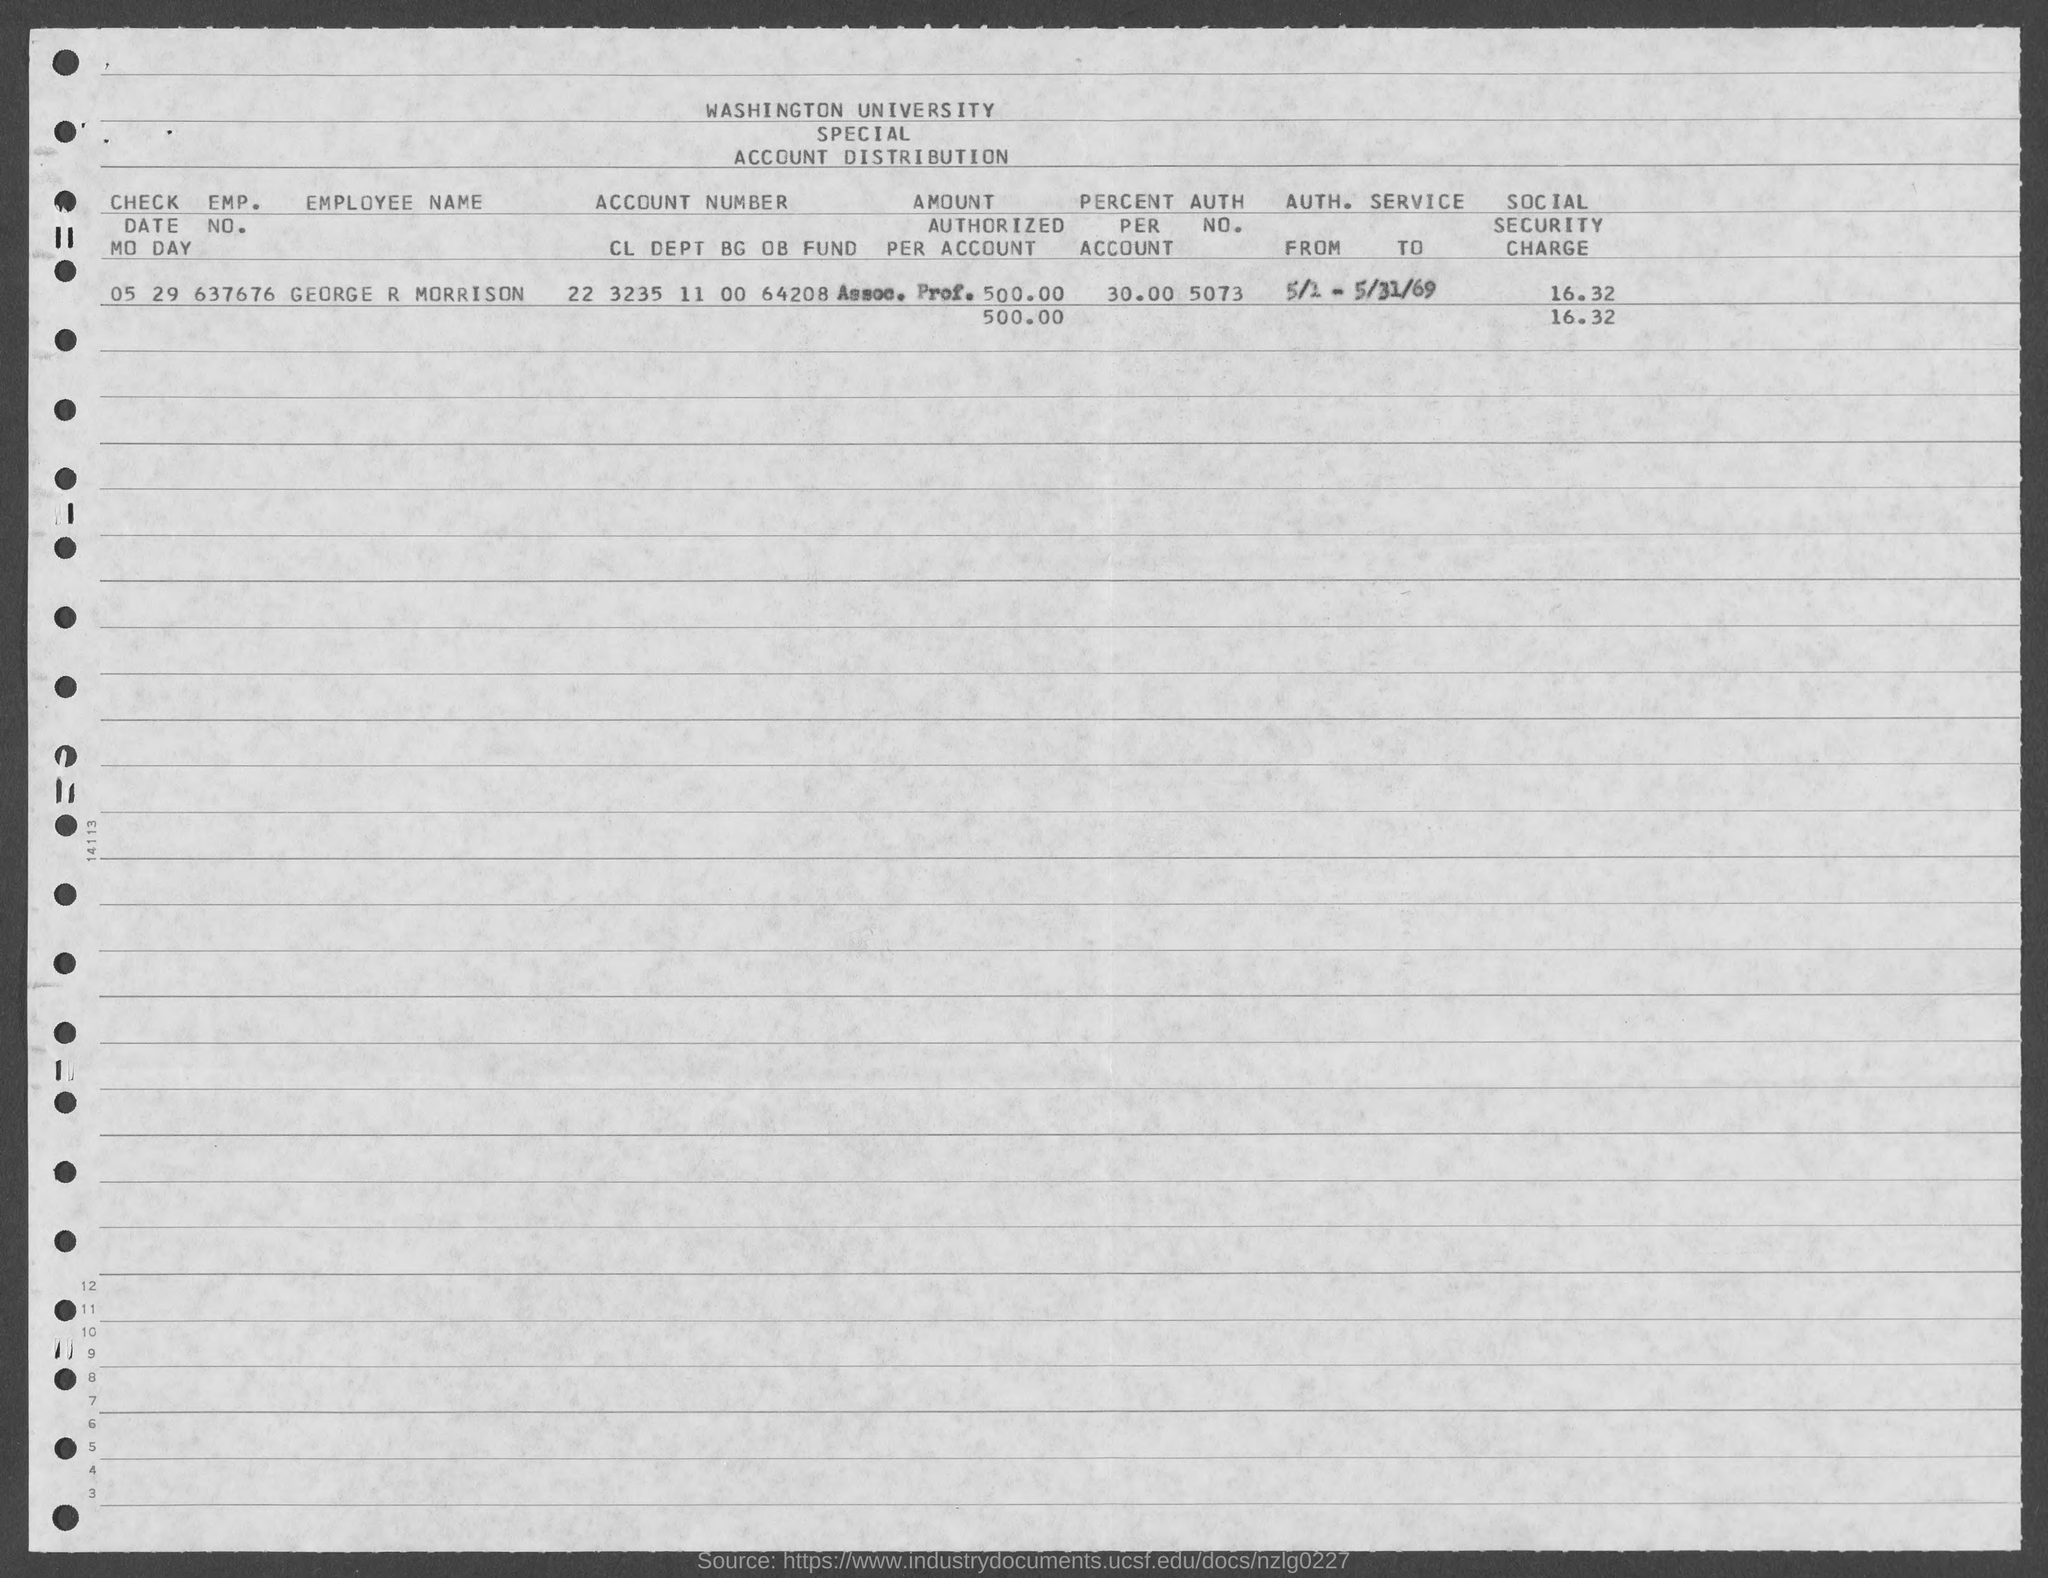Identify some key points in this picture. The Social Security charge is 16.32. The percentage is 30.00 for each account. The employee's name is George R Morrison. What is the employee number? 637676... 